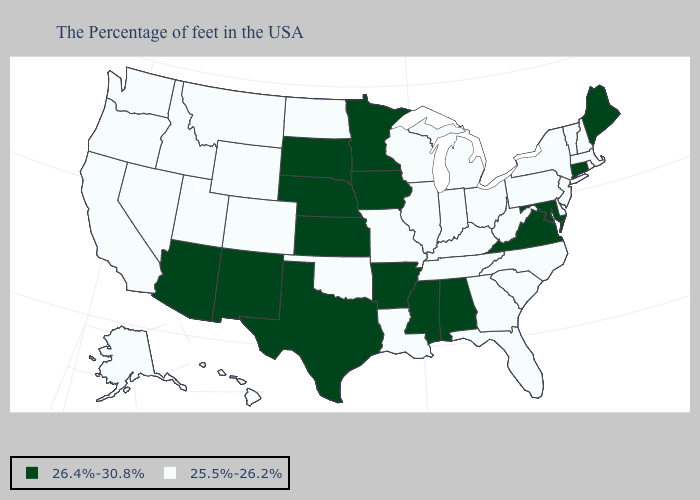What is the value of Michigan?
Short answer required. 25.5%-26.2%. Name the states that have a value in the range 26.4%-30.8%?
Concise answer only. Maine, Connecticut, Maryland, Virginia, Alabama, Mississippi, Arkansas, Minnesota, Iowa, Kansas, Nebraska, Texas, South Dakota, New Mexico, Arizona. Name the states that have a value in the range 25.5%-26.2%?
Keep it brief. Massachusetts, Rhode Island, New Hampshire, Vermont, New York, New Jersey, Delaware, Pennsylvania, North Carolina, South Carolina, West Virginia, Ohio, Florida, Georgia, Michigan, Kentucky, Indiana, Tennessee, Wisconsin, Illinois, Louisiana, Missouri, Oklahoma, North Dakota, Wyoming, Colorado, Utah, Montana, Idaho, Nevada, California, Washington, Oregon, Alaska, Hawaii. Name the states that have a value in the range 26.4%-30.8%?
Concise answer only. Maine, Connecticut, Maryland, Virginia, Alabama, Mississippi, Arkansas, Minnesota, Iowa, Kansas, Nebraska, Texas, South Dakota, New Mexico, Arizona. Does Maryland have the highest value in the South?
Write a very short answer. Yes. What is the highest value in the West ?
Answer briefly. 26.4%-30.8%. Which states have the lowest value in the MidWest?
Write a very short answer. Ohio, Michigan, Indiana, Wisconsin, Illinois, Missouri, North Dakota. What is the value of South Carolina?
Give a very brief answer. 25.5%-26.2%. Does the first symbol in the legend represent the smallest category?
Keep it brief. No. Which states have the lowest value in the Northeast?
Write a very short answer. Massachusetts, Rhode Island, New Hampshire, Vermont, New York, New Jersey, Pennsylvania. What is the lowest value in states that border Arizona?
Concise answer only. 25.5%-26.2%. Does Delaware have the lowest value in the USA?
Give a very brief answer. Yes. Name the states that have a value in the range 25.5%-26.2%?
Be succinct. Massachusetts, Rhode Island, New Hampshire, Vermont, New York, New Jersey, Delaware, Pennsylvania, North Carolina, South Carolina, West Virginia, Ohio, Florida, Georgia, Michigan, Kentucky, Indiana, Tennessee, Wisconsin, Illinois, Louisiana, Missouri, Oklahoma, North Dakota, Wyoming, Colorado, Utah, Montana, Idaho, Nevada, California, Washington, Oregon, Alaska, Hawaii. How many symbols are there in the legend?
Short answer required. 2. What is the highest value in the USA?
Answer briefly. 26.4%-30.8%. 